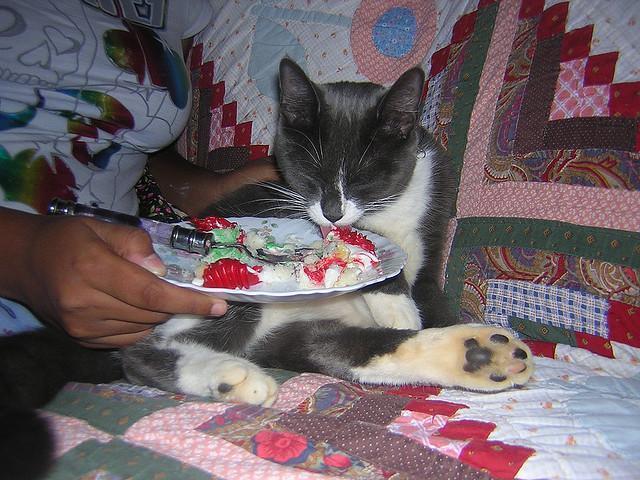How many cats are there?
Give a very brief answer. 1. 